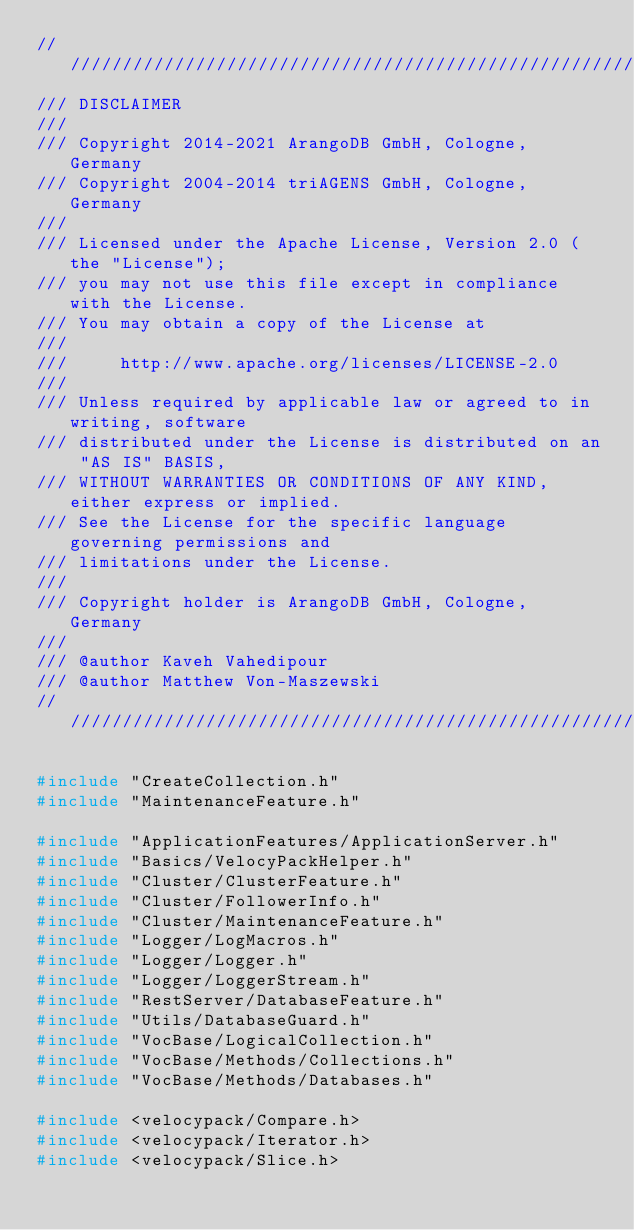Convert code to text. <code><loc_0><loc_0><loc_500><loc_500><_C++_>////////////////////////////////////////////////////////////////////////////////
/// DISCLAIMER
///
/// Copyright 2014-2021 ArangoDB GmbH, Cologne, Germany
/// Copyright 2004-2014 triAGENS GmbH, Cologne, Germany
///
/// Licensed under the Apache License, Version 2.0 (the "License");
/// you may not use this file except in compliance with the License.
/// You may obtain a copy of the License at
///
///     http://www.apache.org/licenses/LICENSE-2.0
///
/// Unless required by applicable law or agreed to in writing, software
/// distributed under the License is distributed on an "AS IS" BASIS,
/// WITHOUT WARRANTIES OR CONDITIONS OF ANY KIND, either express or implied.
/// See the License for the specific language governing permissions and
/// limitations under the License.
///
/// Copyright holder is ArangoDB GmbH, Cologne, Germany
///
/// @author Kaveh Vahedipour
/// @author Matthew Von-Maszewski
////////////////////////////////////////////////////////////////////////////////

#include "CreateCollection.h"
#include "MaintenanceFeature.h"

#include "ApplicationFeatures/ApplicationServer.h"
#include "Basics/VelocyPackHelper.h"
#include "Cluster/ClusterFeature.h"
#include "Cluster/FollowerInfo.h"
#include "Cluster/MaintenanceFeature.h"
#include "Logger/LogMacros.h"
#include "Logger/Logger.h"
#include "Logger/LoggerStream.h"
#include "RestServer/DatabaseFeature.h"
#include "Utils/DatabaseGuard.h"
#include "VocBase/LogicalCollection.h"
#include "VocBase/Methods/Collections.h"
#include "VocBase/Methods/Databases.h"

#include <velocypack/Compare.h>
#include <velocypack/Iterator.h>
#include <velocypack/Slice.h></code> 